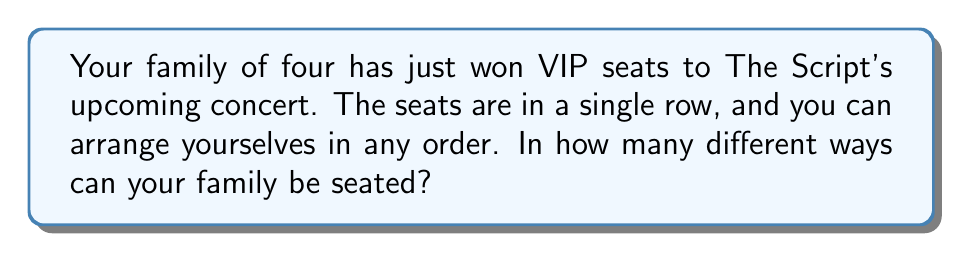Teach me how to tackle this problem. Let's approach this step-by-step:

1) This is a permutation problem. We need to arrange 4 people in a row.

2) For the first seat, we have 4 choices (any of the family members can sit there).

3) After the first person is seated, we have 3 choices for the second seat.

4) For the third seat, we'll have 2 choices left.

5) For the last seat, there's only 1 person left to sit there.

6) According to the multiplication principle, we multiply these numbers together:

   $$4 \times 3 \times 2 \times 1 = 24$$

7) This is also known as 4 factorial, written as $4!$

   $$4! = 4 \times 3 \times 2 \times 1 = 24$$

Therefore, there are 24 different ways to arrange your family in the row of seats at The Script concert.
Answer: $24$ 